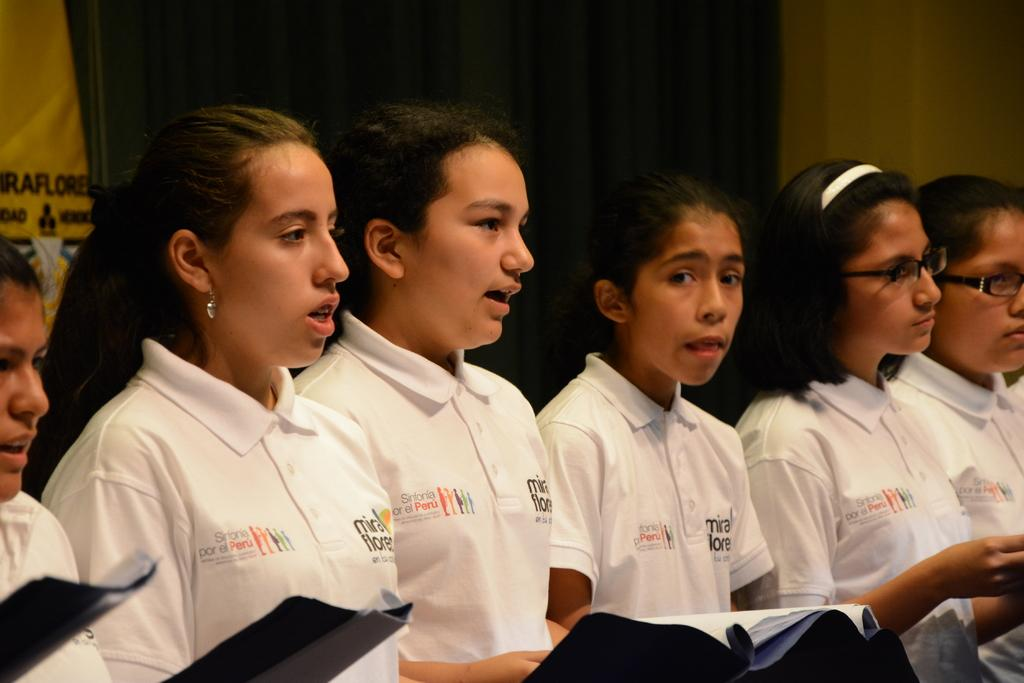How many people are in the image? There are persons in the image, but the exact number is not specified. What are the persons wearing? The persons are wearing clothes. What objects can be seen at the bottom of the image? There are books at the bottom of the image. What type of skirt is the owner of the books wearing in the image? There is no information about a skirt or an owner of the books in the image. 